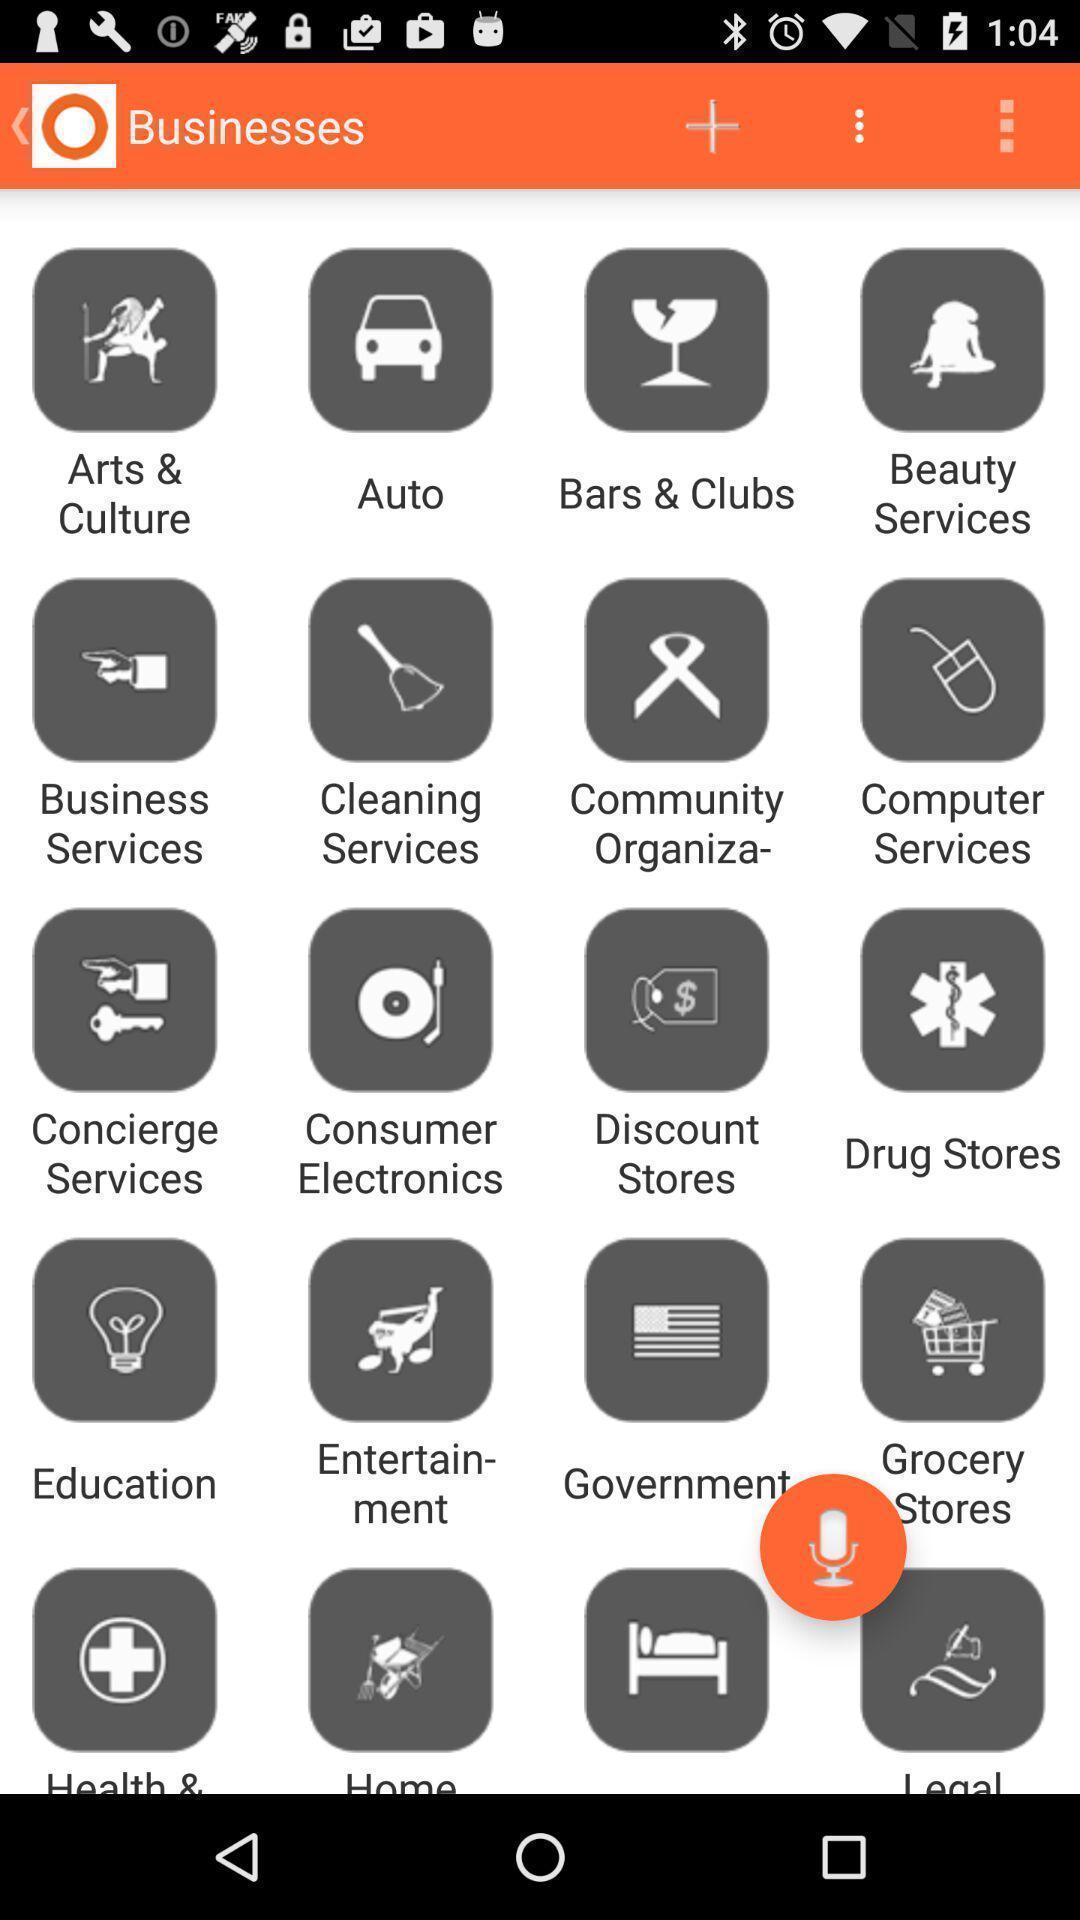What is the overall content of this screenshot? Screen displaying the various businesses. 